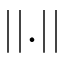<formula> <loc_0><loc_0><loc_500><loc_500>| | . | |</formula> 